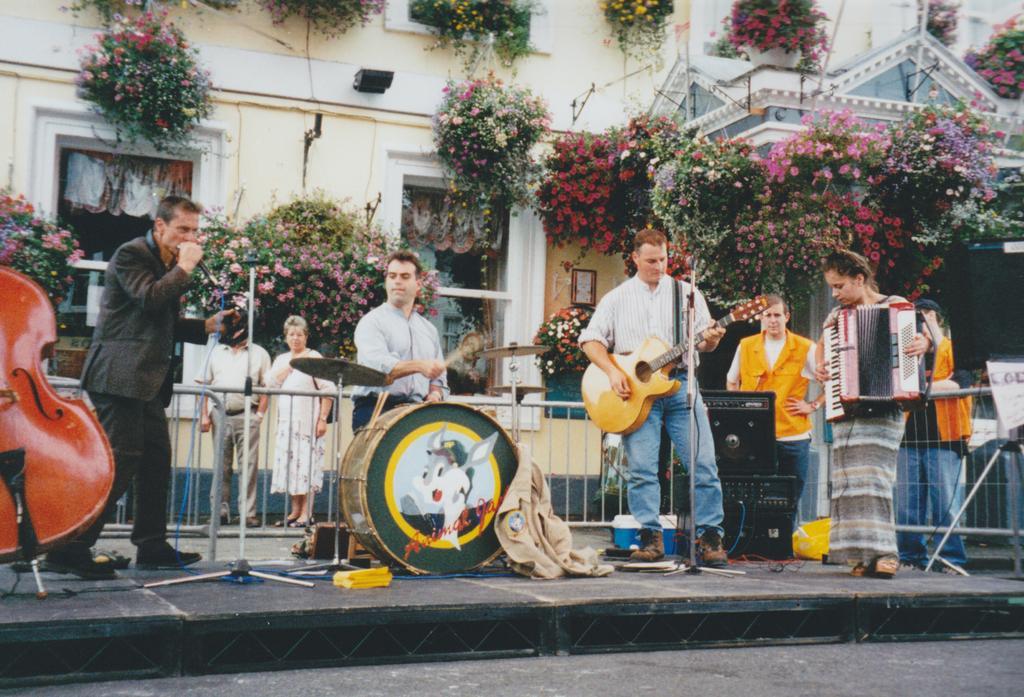Please provide a concise description of this image. In this image there is a person standing and singing a song , another person sitting and playing the drums , another person standing and playing guitar , another person standing and playing a musical instrument, in the background there are group of people standing , speaker , trees , light , building. 